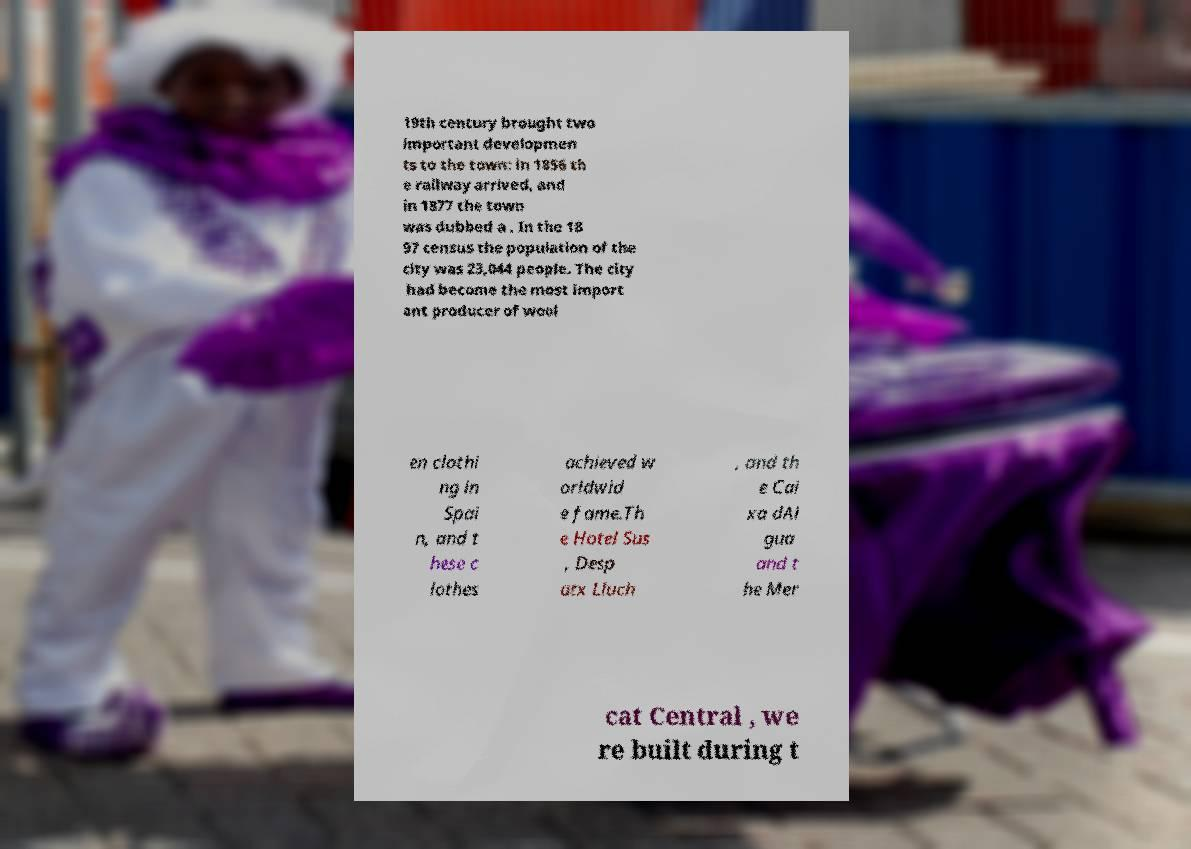For documentation purposes, I need the text within this image transcribed. Could you provide that? 19th century brought two important developmen ts to the town: in 1856 th e railway arrived, and in 1877 the town was dubbed a . In the 18 97 census the population of the city was 23,044 people. The city had become the most import ant producer of wool en clothi ng in Spai n, and t hese c lothes achieved w orldwid e fame.Th e Hotel Sus , Desp atx Lluch , and th e Cai xa dAi gua and t he Mer cat Central , we re built during t 